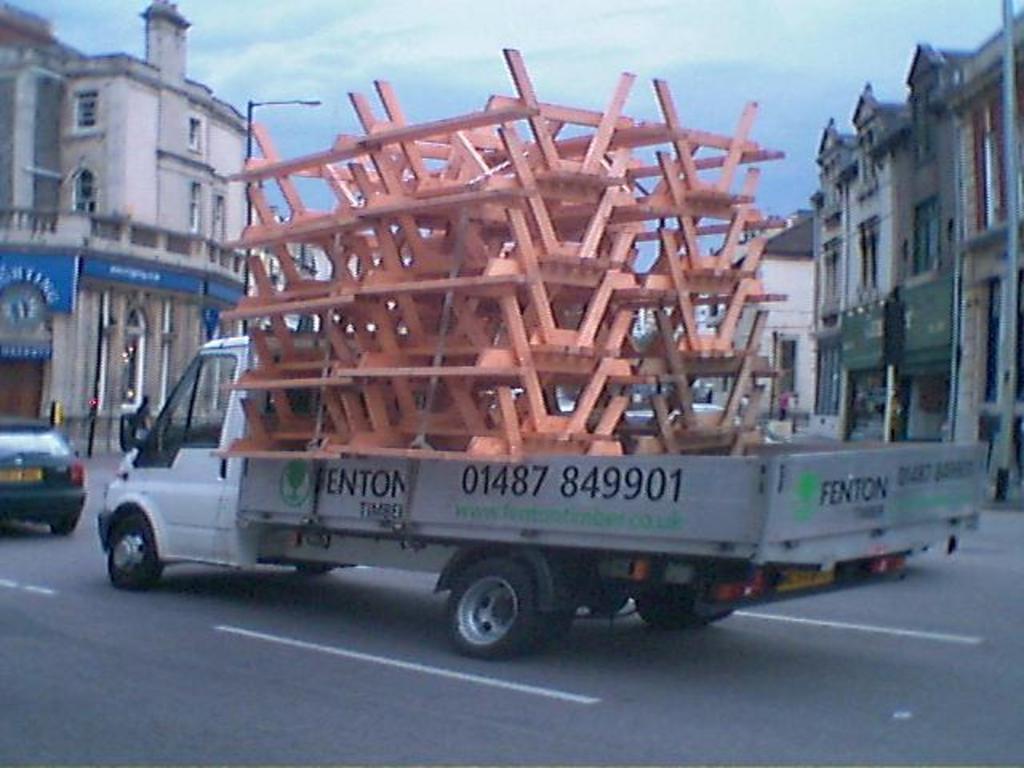Can you describe this image briefly? This picture show about the white color van full of orange color metal rods moving on the road. Behind there are some buildings and above we can see sky and clouds. 